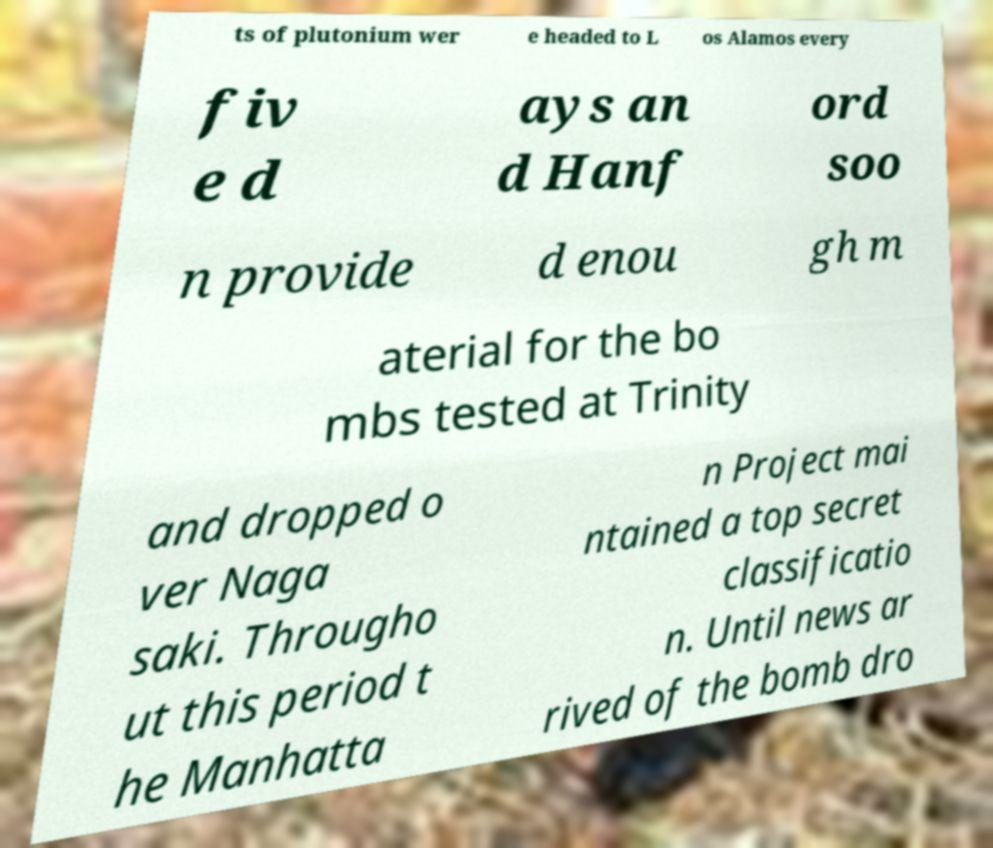Could you extract and type out the text from this image? ts of plutonium wer e headed to L os Alamos every fiv e d ays an d Hanf ord soo n provide d enou gh m aterial for the bo mbs tested at Trinity and dropped o ver Naga saki. Througho ut this period t he Manhatta n Project mai ntained a top secret classificatio n. Until news ar rived of the bomb dro 